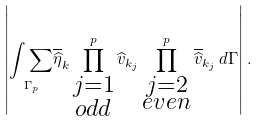Convert formula to latex. <formula><loc_0><loc_0><loc_500><loc_500>\left | \underset { \Gamma _ { p } } { \int \sum } \overline { \widehat { \eta } } _ { k } \prod _ { \substack { j = 1 \\ o d d } } ^ { p } \widehat { v } _ { k _ { j } } \prod _ { \substack { j = 2 \\ e v e n } } ^ { p } \overline { \widehat { v } } _ { k _ { j } } \, d \Gamma \right | .</formula> 